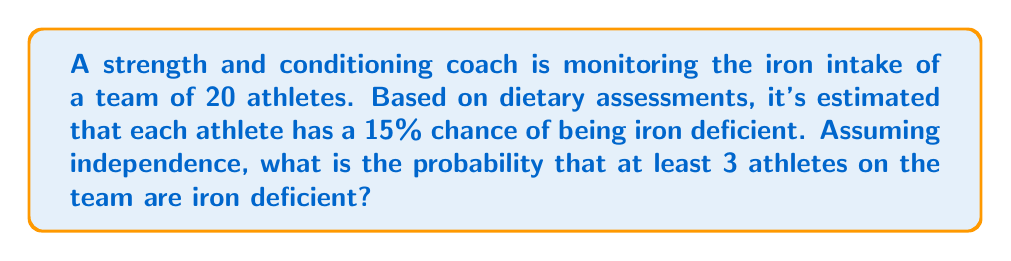Show me your answer to this math problem. To solve this problem, we'll use the binomial probability distribution and the complement rule.

Step 1: Identify the parameters
n = 20 (number of athletes)
p = 0.15 (probability of iron deficiency for each athlete)
q = 1 - p = 0.85 (probability of not being iron deficient)

Step 2: Calculate the probability of at least 3 athletes being iron deficient
This is equivalent to 1 minus the probability of 0, 1, or 2 athletes being iron deficient.

P(X ≥ 3) = 1 - [P(X = 0) + P(X = 1) + P(X = 2)]

Step 3: Use the binomial probability formula
$$P(X = k) = \binom{n}{k} p^k q^{n-k}$$

P(X = 0) = $\binom{20}{0} (0.15)^0 (0.85)^{20} = 0.0388$
P(X = 1) = $\binom{20}{1} (0.15)^1 (0.85)^{19} = 0.1368$
P(X = 2) = $\binom{20}{2} (0.15)^2 (0.85)^{18} = 0.2301$

Step 4: Sum the probabilities and subtract from 1
P(X ≥ 3) = 1 - (0.0388 + 0.1368 + 0.2301)
         = 1 - 0.4057
         = 0.5943

Therefore, the probability that at least 3 athletes on the team are iron deficient is approximately 0.5943 or 59.43%.
Answer: 0.5943 